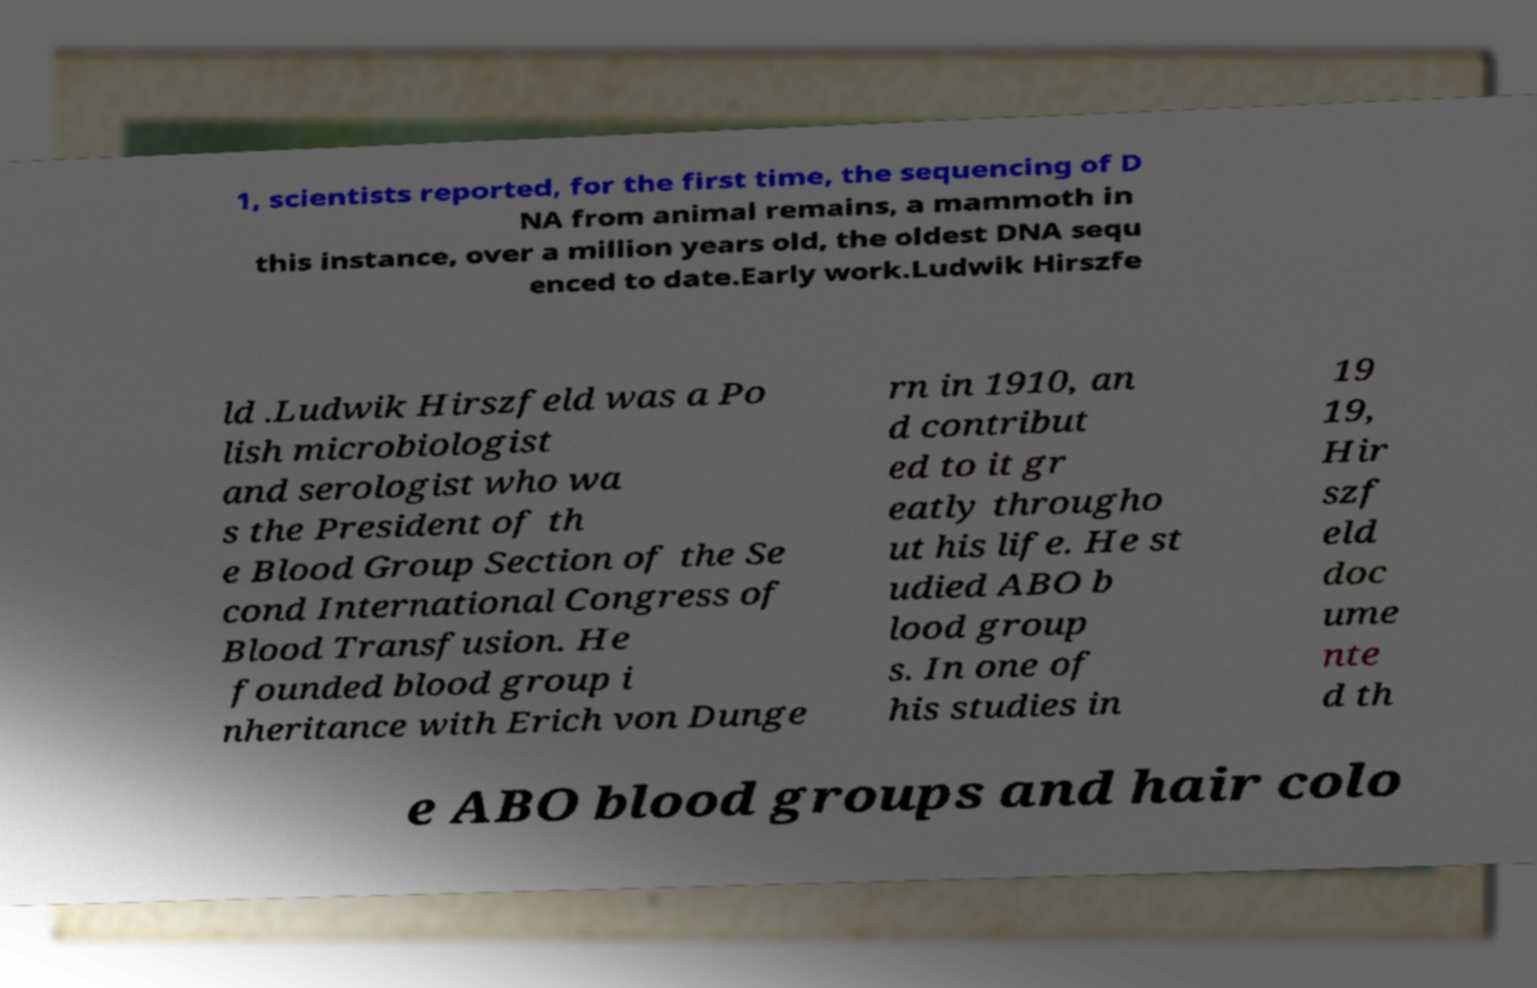What messages or text are displayed in this image? I need them in a readable, typed format. 1, scientists reported, for the first time, the sequencing of D NA from animal remains, a mammoth in this instance, over a million years old, the oldest DNA sequ enced to date.Early work.Ludwik Hirszfe ld .Ludwik Hirszfeld was a Po lish microbiologist and serologist who wa s the President of th e Blood Group Section of the Se cond International Congress of Blood Transfusion. He founded blood group i nheritance with Erich von Dunge rn in 1910, an d contribut ed to it gr eatly througho ut his life. He st udied ABO b lood group s. In one of his studies in 19 19, Hir szf eld doc ume nte d th e ABO blood groups and hair colo 